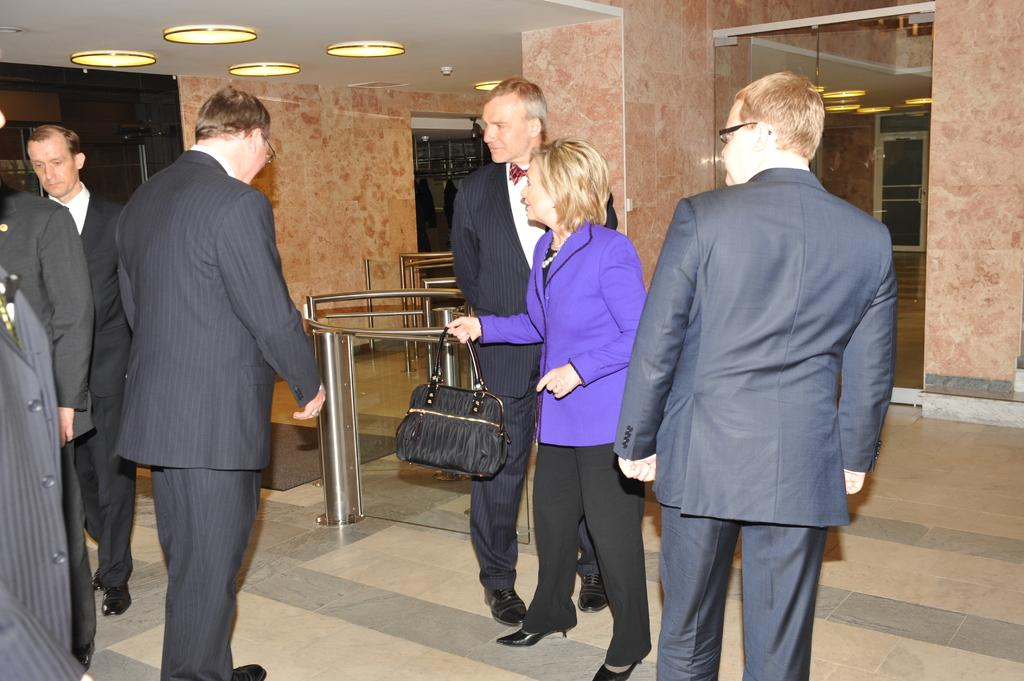What is the main subject of the image? The main subject of the image is a group of people. What are the people in the image doing? The people are standing. Can you describe the woman in the purple jacket? The woman in the purple jacket is holding a handbag. What can be seen in the background of the image? There are lights visible in the image. What type of clothing can be seen on some of the people in the image? Some persons are wearing black suits. Where is the patch of waste located in the image? There is no patch of waste present in the image. What type of wheel can be seen on the woman in the purple jacket? The woman in the purple jacket is not wearing any wheels; she is holding a handbag. 